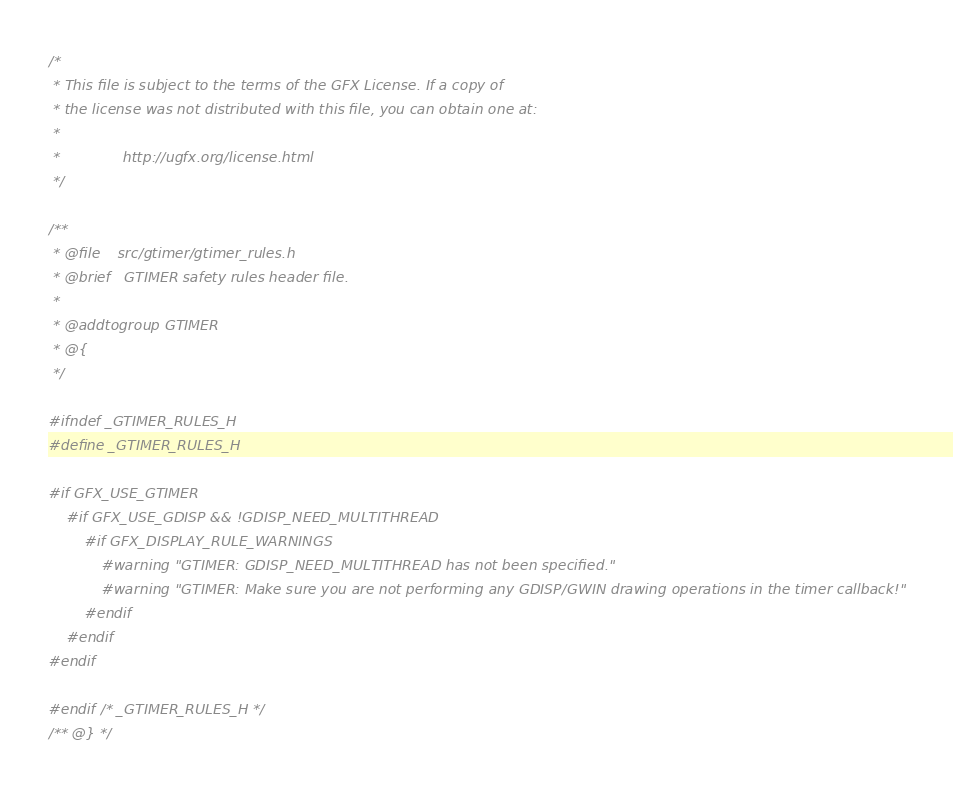Convert code to text. <code><loc_0><loc_0><loc_500><loc_500><_C_>/*
 * This file is subject to the terms of the GFX License. If a copy of
 * the license was not distributed with this file, you can obtain one at:
 *
 *              http://ugfx.org/license.html
 */

/**
 * @file    src/gtimer/gtimer_rules.h
 * @brief   GTIMER safety rules header file.
 *
 * @addtogroup GTIMER
 * @{
 */

#ifndef _GTIMER_RULES_H
#define _GTIMER_RULES_H

#if GFX_USE_GTIMER
	#if GFX_USE_GDISP && !GDISP_NEED_MULTITHREAD
		#if GFX_DISPLAY_RULE_WARNINGS
			#warning "GTIMER: GDISP_NEED_MULTITHREAD has not been specified."
			#warning "GTIMER: Make sure you are not performing any GDISP/GWIN drawing operations in the timer callback!"
		#endif
	#endif
#endif

#endif /* _GTIMER_RULES_H */
/** @} */
</code> 